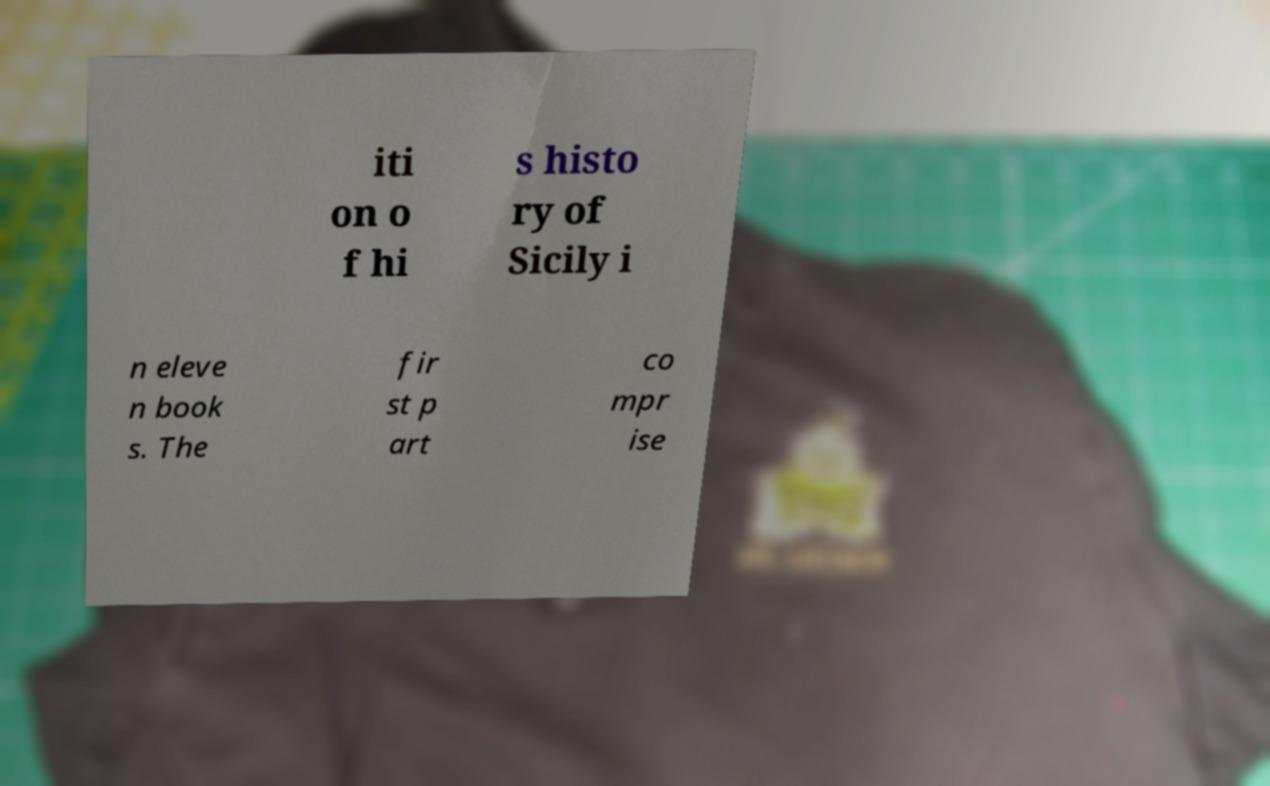What messages or text are displayed in this image? I need them in a readable, typed format. iti on o f hi s histo ry of Sicily i n eleve n book s. The fir st p art co mpr ise 